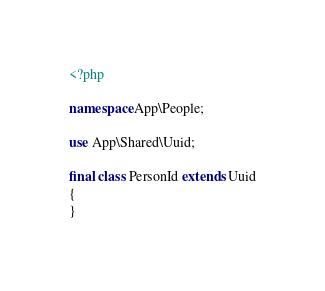Convert code to text. <code><loc_0><loc_0><loc_500><loc_500><_PHP_><?php

namespace App\People;

use App\Shared\Uuid;

final class PersonId extends Uuid
{
}
</code> 